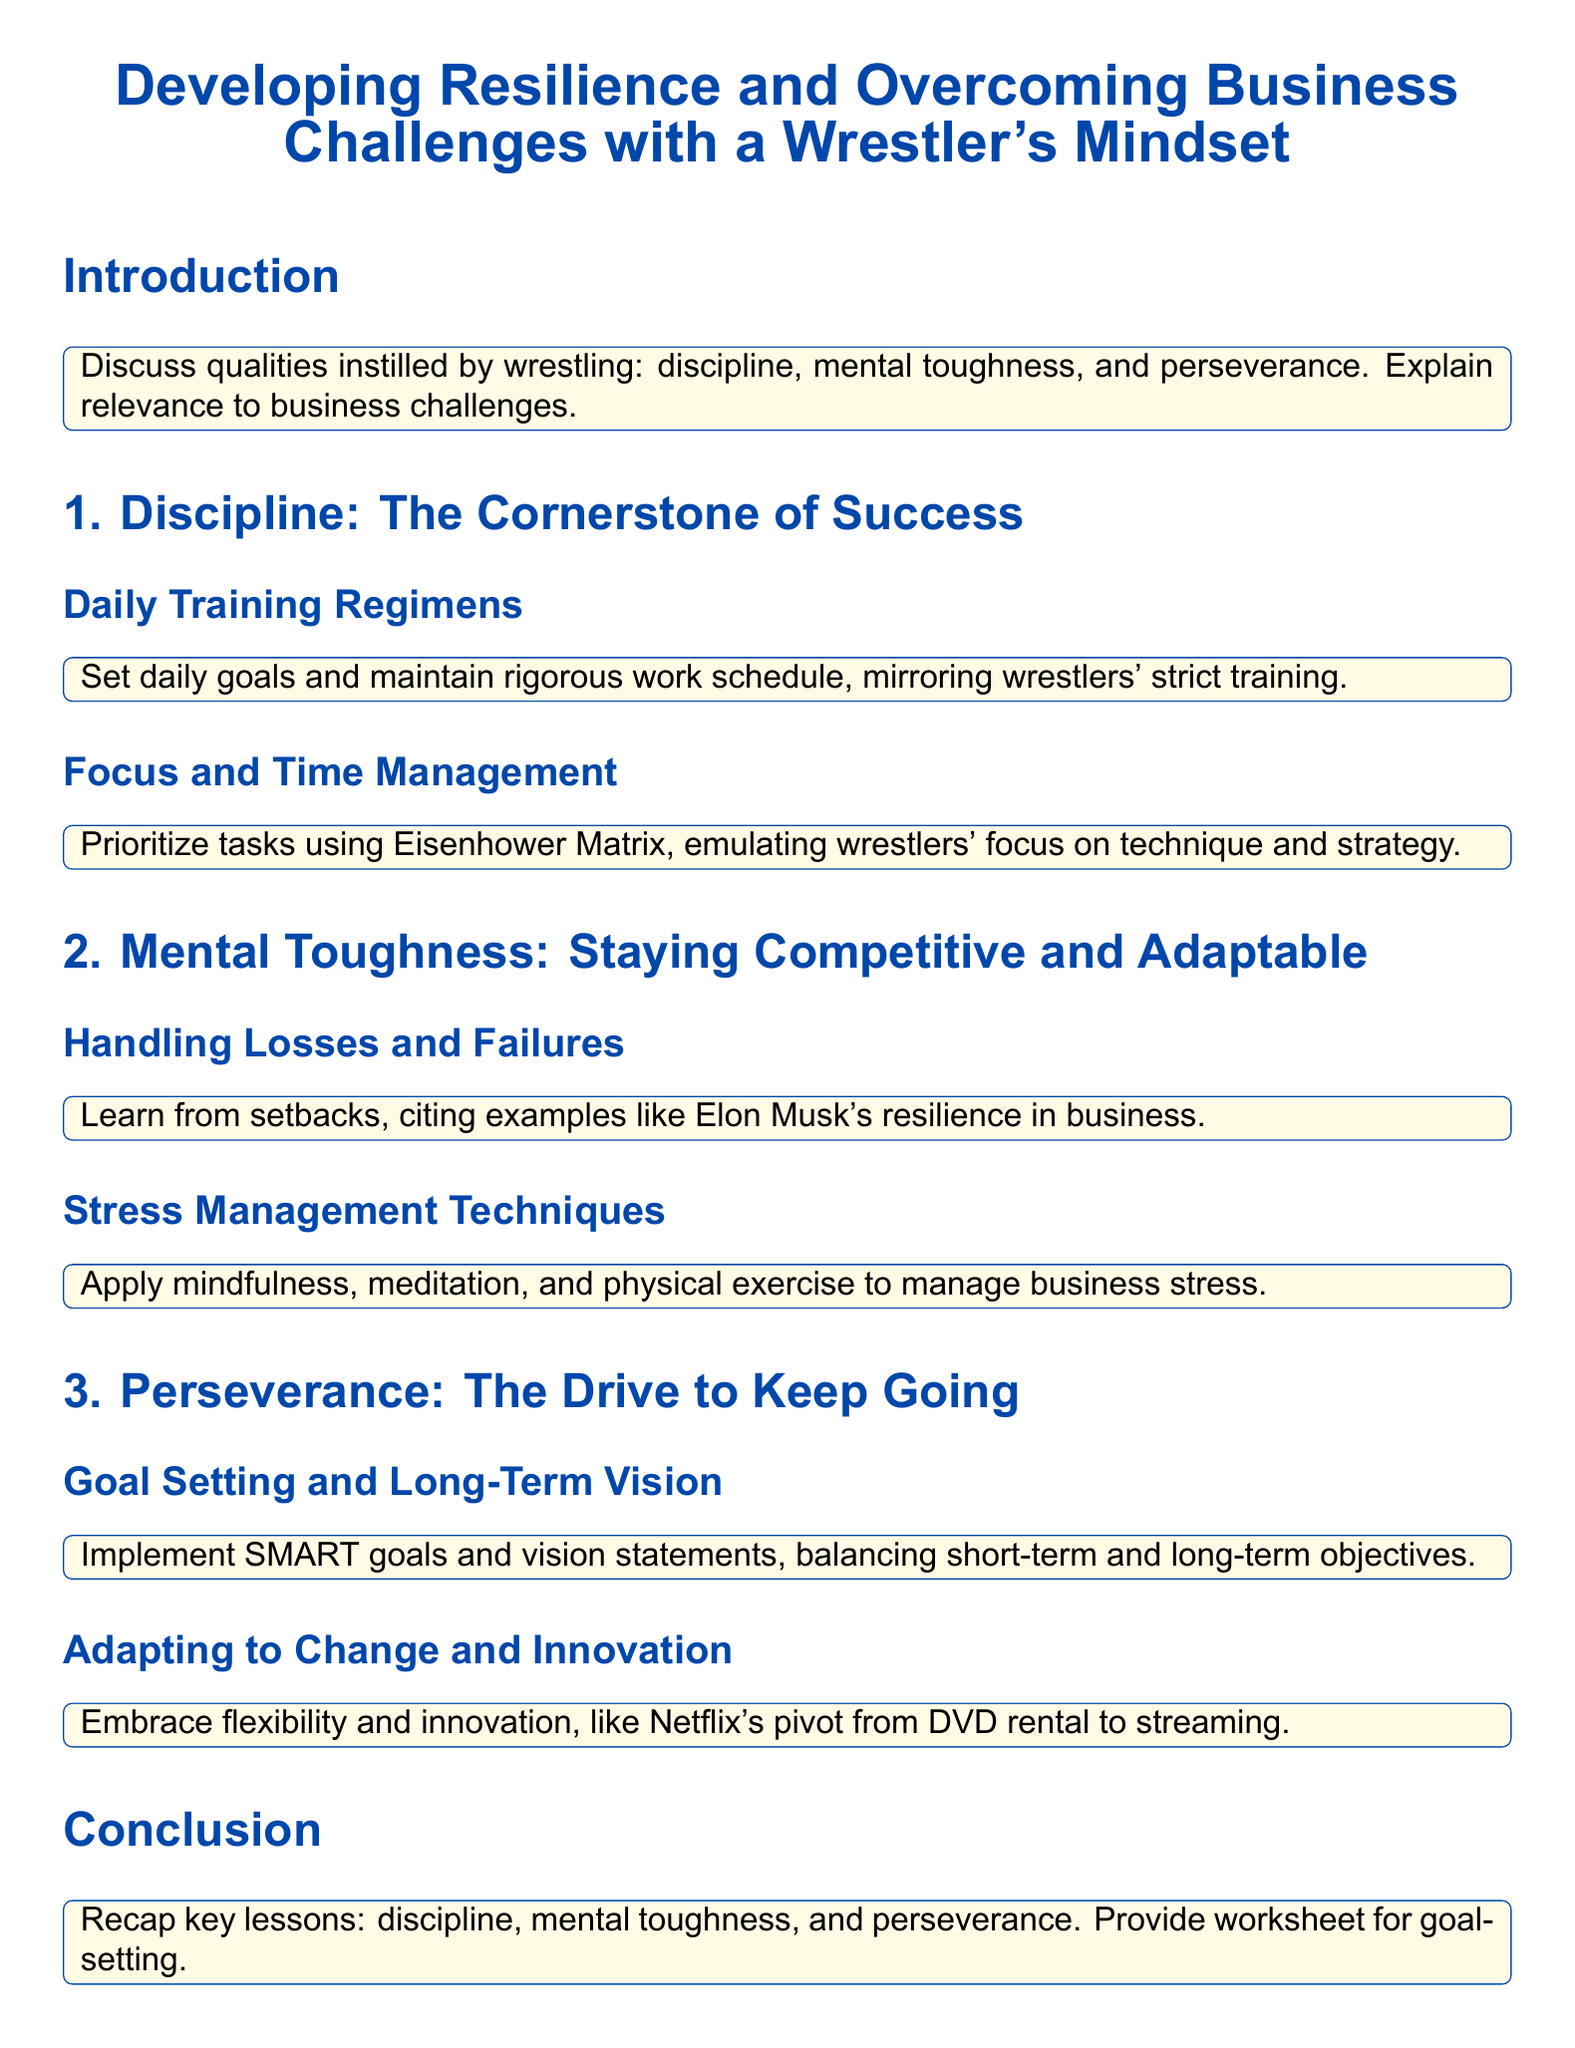What is the main title of the document? The main title is presented at the beginning of the document, highlighting the focus of the lesson plan.
Answer: Developing Resilience and Overcoming Business Challenges with a Wrestler's Mindset What concept does the document emphasize as the cornerstone of success? The document specifically refers to a key principle that is foundational for achieving success in both wrestling and business.
Answer: Discipline Which method is recommended for prioritizing tasks? The document suggests a method that is commonly used for task prioritization, which helps maintain focus and efficiency.
Answer: Eisenhower Matrix What should be implemented for goal setting according to the document? The document outlines a specific framework that is crucial for setting and achieving goals effectively.
Answer: SMART goals Which famous entrepreneur is cited as an example of resilience? An individual known for his notable resilience and multiple successes in business is mentioned in the context of handling failures.
Answer: Elon Musk What is one stress management technique mentioned in the document? The document provides techniques to manage stress effectively, and one of them involves a mental practice aimed at enhancing focus and reducing tension.
Answer: Mindfulness What are the two qualities highlighted under "Mental Toughness"? The document discusses important attributes that are vital for maintaining competitiveness and adaptability in challenging circumstances.
Answer: Handling Losses and Failures, Stress Management Techniques What type of goals should balance both short-term and long-term objectives? The framework discussed in the document is specifically designed to enhance clarity and measurement in goal setting across different time horizons.
Answer: SMART goals What is a key lesson recap provided in the conclusion? The conclusion summarizes essential takeaways from the lesson plan, reinforcing critical qualities relevant for success in business.
Answer: Discipline, mental toughness, and perseverance 